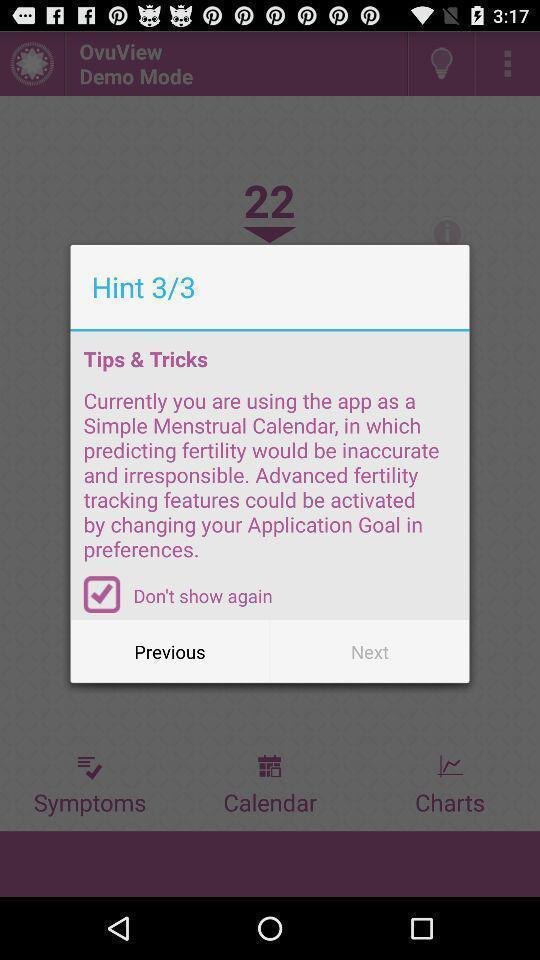Give me a narrative description of this picture. Pop-up for the health application. 